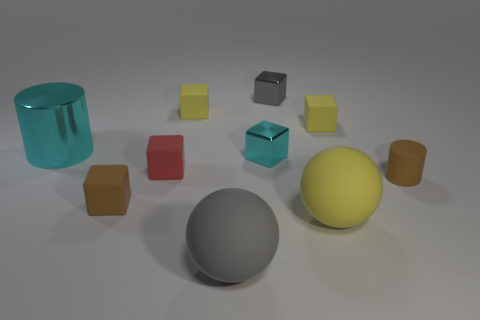Is there a tiny cyan object that has the same shape as the red object?
Give a very brief answer. Yes. There is a cylinder that is the same size as the brown cube; what color is it?
Provide a succinct answer. Brown. There is a cyan thing that is on the right side of the red thing; what material is it?
Provide a short and direct response. Metal. There is a cyan object on the right side of the big cyan metallic object; is its shape the same as the yellow object in front of the small cyan block?
Ensure brevity in your answer.  No. Are there the same number of cyan objects behind the tiny red object and cyan metallic objects?
Offer a very short reply. Yes. How many big gray objects are made of the same material as the big cylinder?
Ensure brevity in your answer.  0. There is a cylinder that is made of the same material as the brown cube; what color is it?
Your response must be concise. Brown. There is a yellow rubber ball; does it have the same size as the red thing that is to the right of the large cyan metallic thing?
Your response must be concise. No. The tiny red rubber thing is what shape?
Provide a succinct answer. Cube. How many shiny blocks have the same color as the large metal thing?
Make the answer very short. 1. 